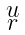<formula> <loc_0><loc_0><loc_500><loc_500>\begin{smallmatrix} u \\ r \end{smallmatrix}</formula> 